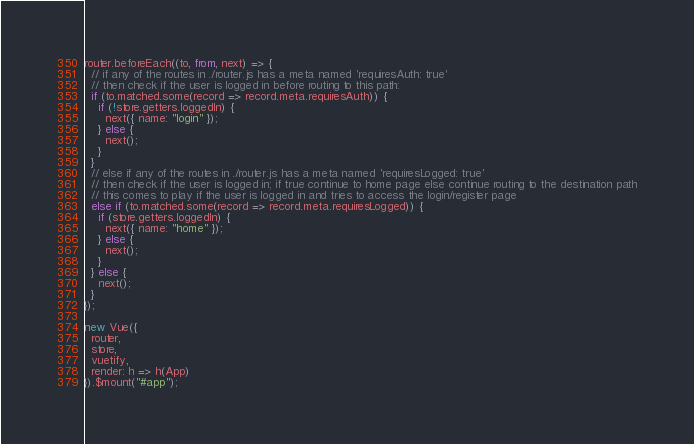<code> <loc_0><loc_0><loc_500><loc_500><_JavaScript_>
router.beforeEach((to, from, next) => {
  // if any of the routes in ./router.js has a meta named 'requiresAuth: true'
  // then check if the user is logged in before routing to this path:
  if (to.matched.some(record => record.meta.requiresAuth)) {
    if (!store.getters.loggedIn) {
      next({ name: "login" });
    } else {
      next();
    }
  }
  // else if any of the routes in ./router.js has a meta named 'requiresLogged: true'
  // then check if the user is logged in; if true continue to home page else continue routing to the destination path
  // this comes to play if the user is logged in and tries to access the login/register page
  else if (to.matched.some(record => record.meta.requiresLogged)) {
    if (store.getters.loggedIn) {
      next({ name: "home" });
    } else {
      next();
    }
  } else {
    next();
  }
});

new Vue({
  router,
  store,
  vuetify,
  render: h => h(App)
}).$mount("#app");
</code> 